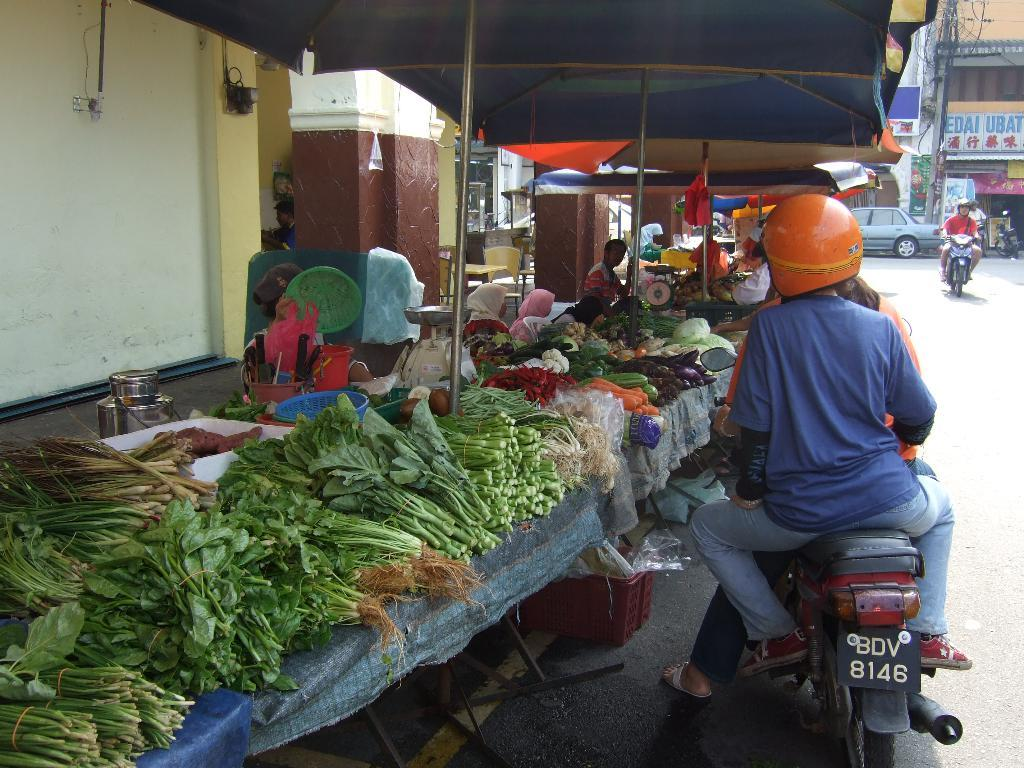What type of structure can be seen in the image? There is a wall in the image. What items are on the table in the image? There are vegetables on a table in the image. What vehicles are present on the road in the image? There is a car and a motorcycle on the road in the image. What type of building is visible in the image? There is a building in the image. Can you see any roses growing near the building in the image? There are no roses visible in the image. Is there a scarf hanging from the wall in the image? There is no scarf present in the image. 